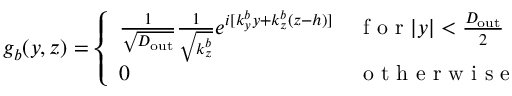<formula> <loc_0><loc_0><loc_500><loc_500>g _ { b } ( y , z ) = \left \{ \begin{array} { l l } { \frac { 1 } { \sqrt { D _ { o u t } } } \frac { 1 } { \sqrt { k _ { z } ^ { b } } } e ^ { i [ k _ { y } ^ { b } y + k _ { z } ^ { b } ( z - h ) ] } } & { f o r | y | < \frac { D _ { o u t } } { 2 } } \\ { 0 } & { o t h e r w i s e } \end{array}</formula> 